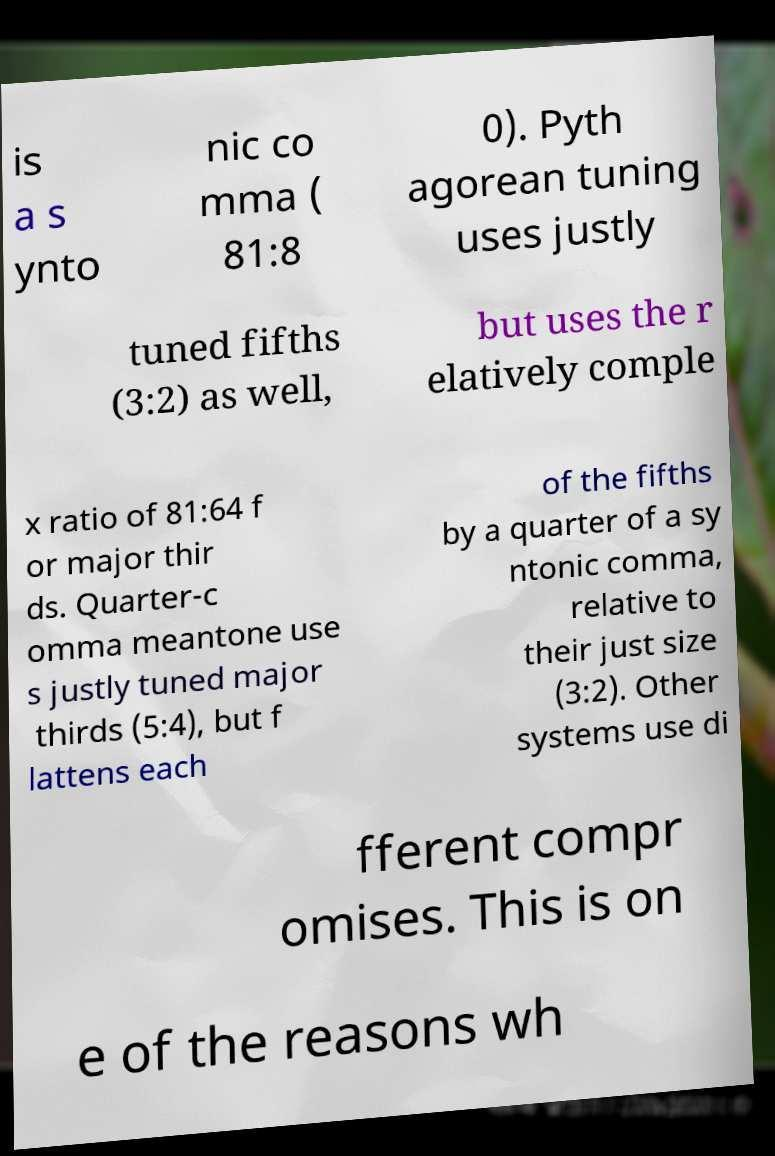I need the written content from this picture converted into text. Can you do that? is a s ynto nic co mma ( 81:8 0). Pyth agorean tuning uses justly tuned fifths (3:2) as well, but uses the r elatively comple x ratio of 81:64 f or major thir ds. Quarter-c omma meantone use s justly tuned major thirds (5:4), but f lattens each of the fifths by a quarter of a sy ntonic comma, relative to their just size (3:2). Other systems use di fferent compr omises. This is on e of the reasons wh 